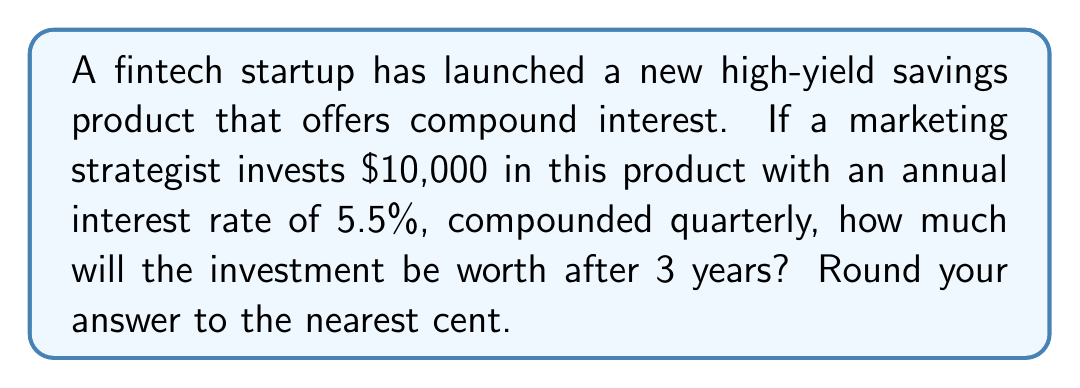Show me your answer to this math problem. To solve this problem, we'll use the compound interest formula:

$$A = P(1 + \frac{r}{n})^{nt}$$

Where:
$A$ = final amount
$P$ = principal (initial investment)
$r$ = annual interest rate (as a decimal)
$n$ = number of times interest is compounded per year
$t$ = number of years

Given:
$P = \$10,000$
$r = 5.5\% = 0.055$
$n = 4$ (compounded quarterly)
$t = 3$ years

Let's plug these values into the formula:

$$A = 10000(1 + \frac{0.055}{4})^{4 \times 3}$$

$$A = 10000(1 + 0.01375)^{12}$$

$$A = 10000(1.01375)^{12}$$

Using a calculator or spreadsheet to compute this:

$$A = 10000 \times 1.177656$$

$$A = 11,776.56$$
Answer: $11,776.56 